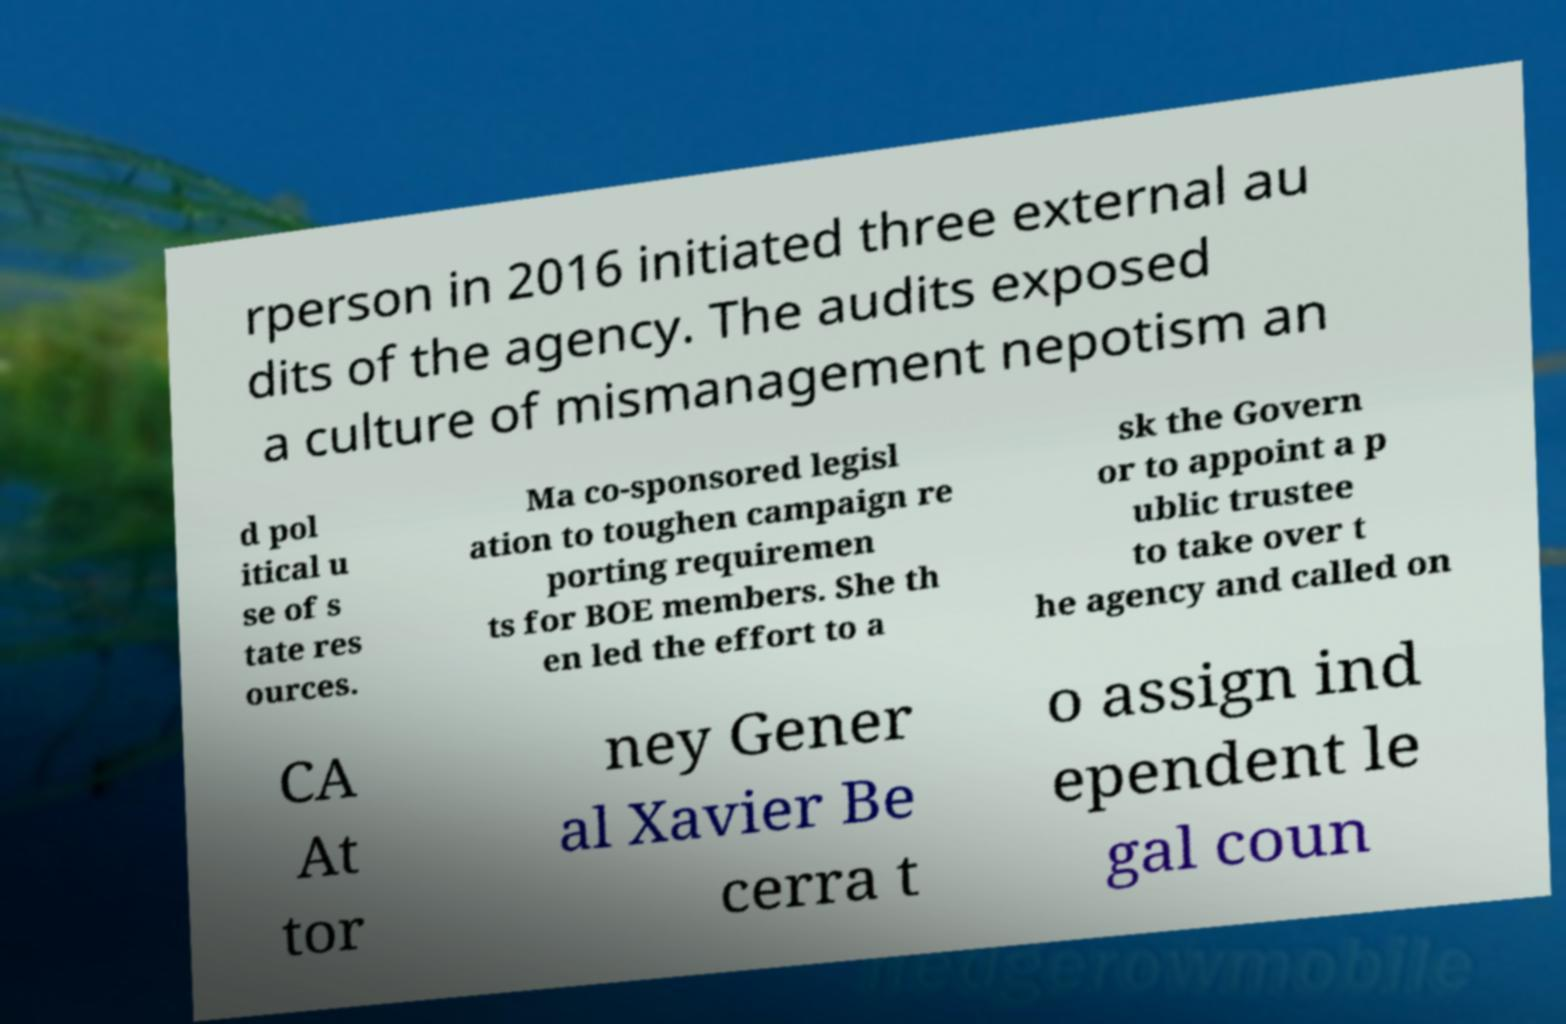Could you extract and type out the text from this image? rperson in 2016 initiated three external au dits of the agency. The audits exposed a culture of mismanagement nepotism an d pol itical u se of s tate res ources. Ma co-sponsored legisl ation to toughen campaign re porting requiremen ts for BOE members. She th en led the effort to a sk the Govern or to appoint a p ublic trustee to take over t he agency and called on CA At tor ney Gener al Xavier Be cerra t o assign ind ependent le gal coun 